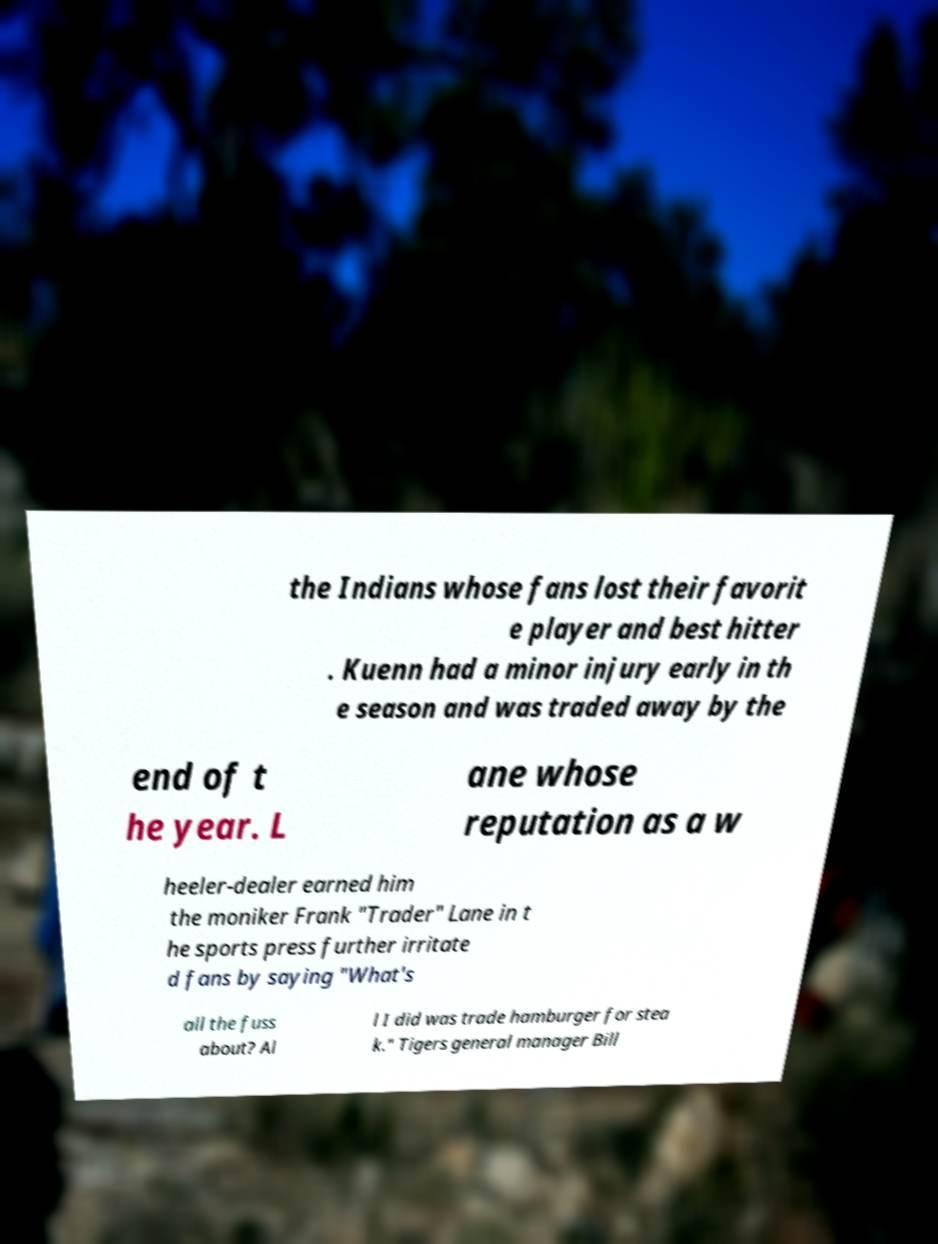What messages or text are displayed in this image? I need them in a readable, typed format. the Indians whose fans lost their favorit e player and best hitter . Kuenn had a minor injury early in th e season and was traded away by the end of t he year. L ane whose reputation as a w heeler-dealer earned him the moniker Frank "Trader" Lane in t he sports press further irritate d fans by saying "What's all the fuss about? Al l I did was trade hamburger for stea k." Tigers general manager Bill 